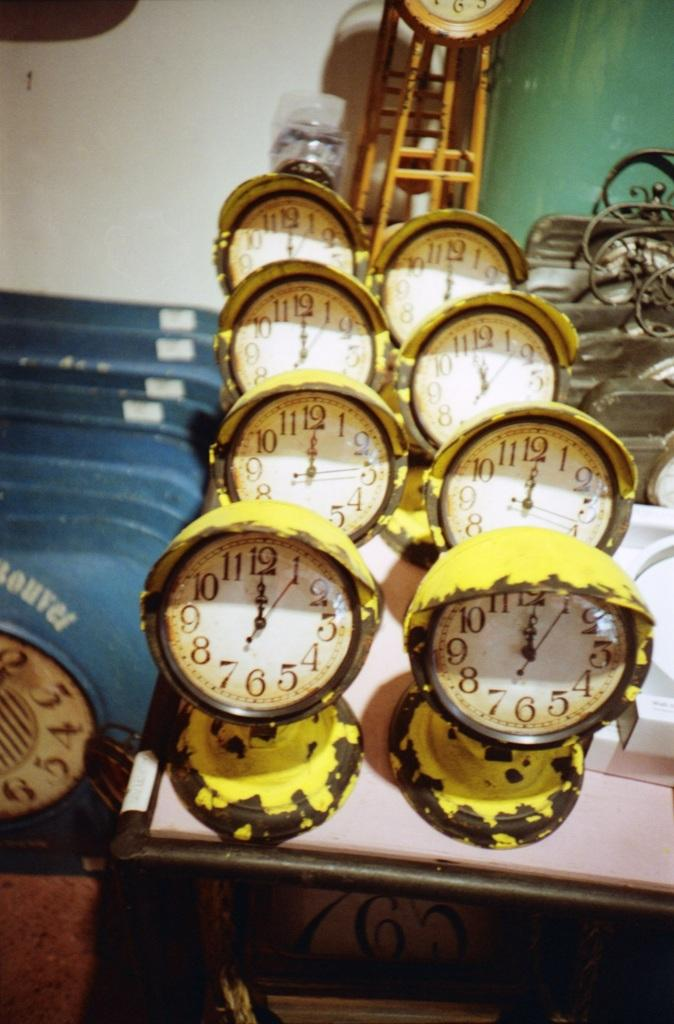Provide a one-sentence caption for the provided image. A row of yellow clocks are sitting on a table and they all show the time to be midnight. 